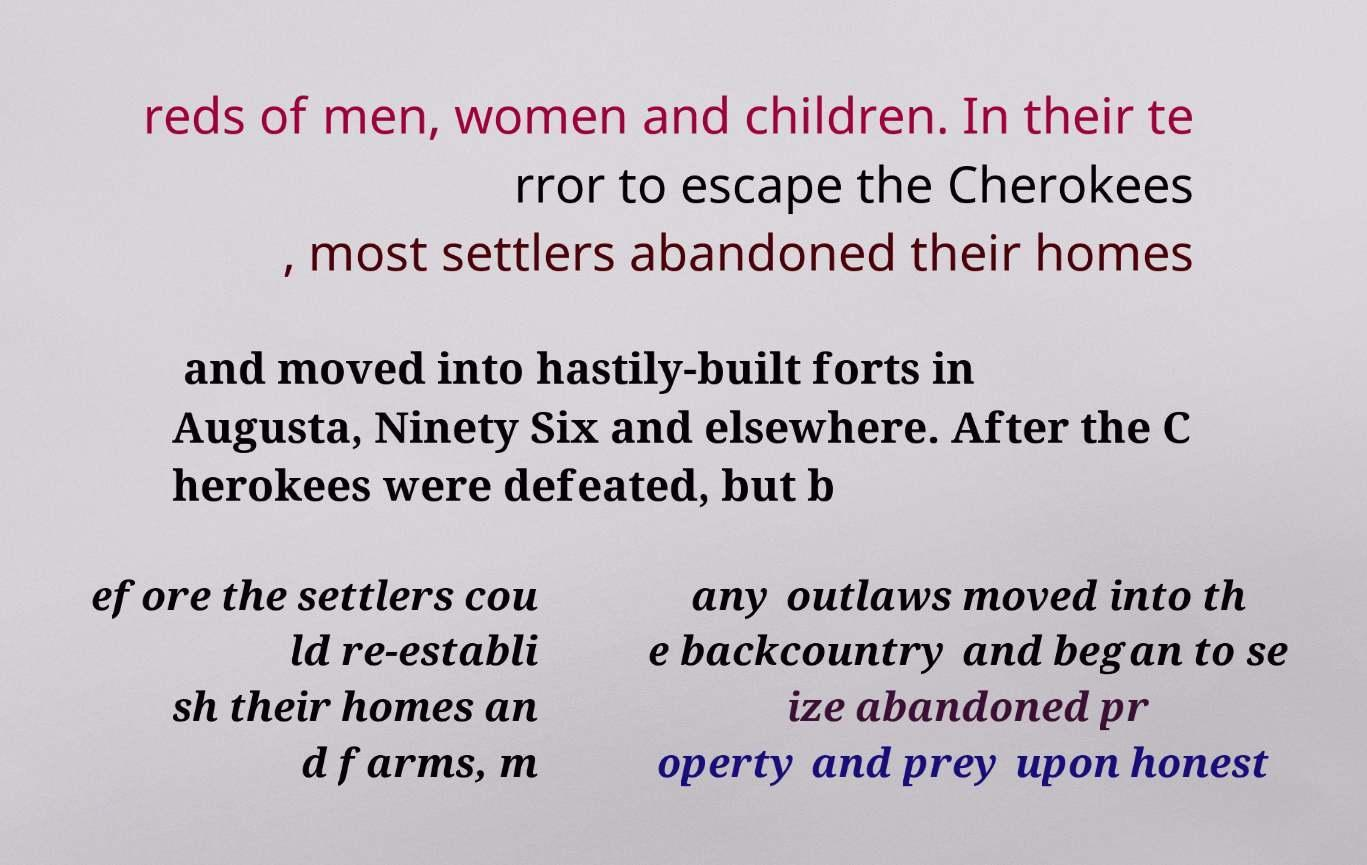There's text embedded in this image that I need extracted. Can you transcribe it verbatim? reds of men, women and children. In their te rror to escape the Cherokees , most settlers abandoned their homes and moved into hastily-built forts in Augusta, Ninety Six and elsewhere. After the C herokees were defeated, but b efore the settlers cou ld re-establi sh their homes an d farms, m any outlaws moved into th e backcountry and began to se ize abandoned pr operty and prey upon honest 